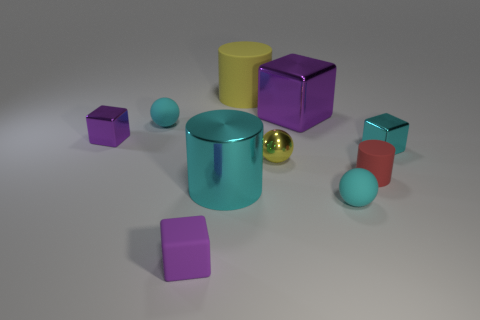How many purple cubes must be subtracted to get 1 purple cubes? 2 Subtract all red cylinders. How many purple cubes are left? 3 Subtract 1 blocks. How many blocks are left? 3 Subtract all balls. How many objects are left? 7 Add 1 small red rubber objects. How many small red rubber objects are left? 2 Add 3 small brown matte cubes. How many small brown matte cubes exist? 3 Subtract 0 purple balls. How many objects are left? 10 Subtract all small gray things. Subtract all tiny cyan rubber objects. How many objects are left? 8 